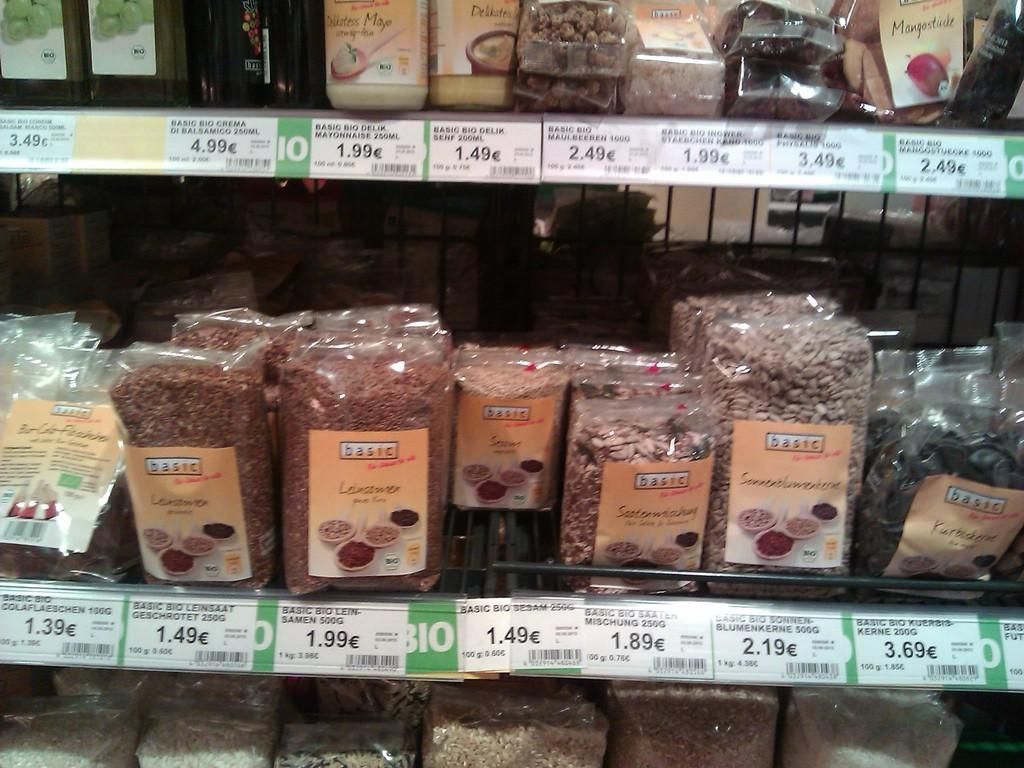<image>
Write a terse but informative summary of the picture. A shopping display for various types of Basic brand dried beans. 